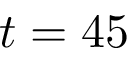Convert formula to latex. <formula><loc_0><loc_0><loc_500><loc_500>t = 4 5</formula> 